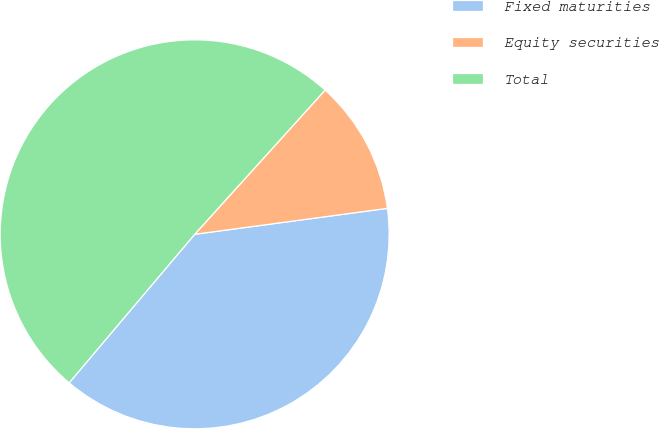Convert chart to OTSL. <chart><loc_0><loc_0><loc_500><loc_500><pie_chart><fcel>Fixed maturities<fcel>Equity securities<fcel>Total<nl><fcel>38.3%<fcel>11.17%<fcel>50.54%<nl></chart> 